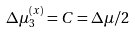Convert formula to latex. <formula><loc_0><loc_0><loc_500><loc_500>\Delta \mu _ { 3 } ^ { \left ( x \right ) } = C = \Delta \mu / 2</formula> 